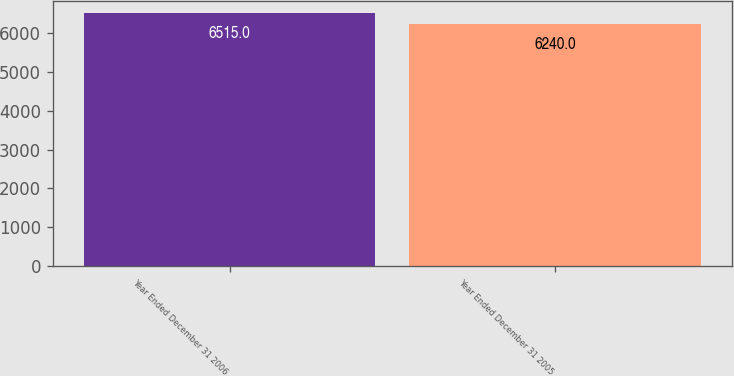Convert chart to OTSL. <chart><loc_0><loc_0><loc_500><loc_500><bar_chart><fcel>Year Ended December 31 2006<fcel>Year Ended December 31 2005<nl><fcel>6515<fcel>6240<nl></chart> 